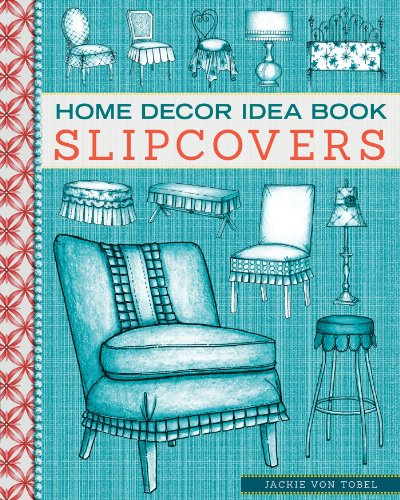What might someone learn from this book based on the cover? From the book cover, a reader can expect to learn about various techniques and ideas for upholstering chairs, designing slipcovers, and crafting seat cushions. The illustrations highlight different approaches, suggesting a focus on practical, creative solutions for enhancing home decor. How could this book be useful for a beginner in upholstery? For a beginner, this book would serve as an excellent introduction, providing step-by-step instructions and visual guides on basic upholstery techniques. The detailed illustrations can help in understanding fabric cuts, sewing methods, and fitting slipcovers, making it easier to undertake DIY projects at home. 